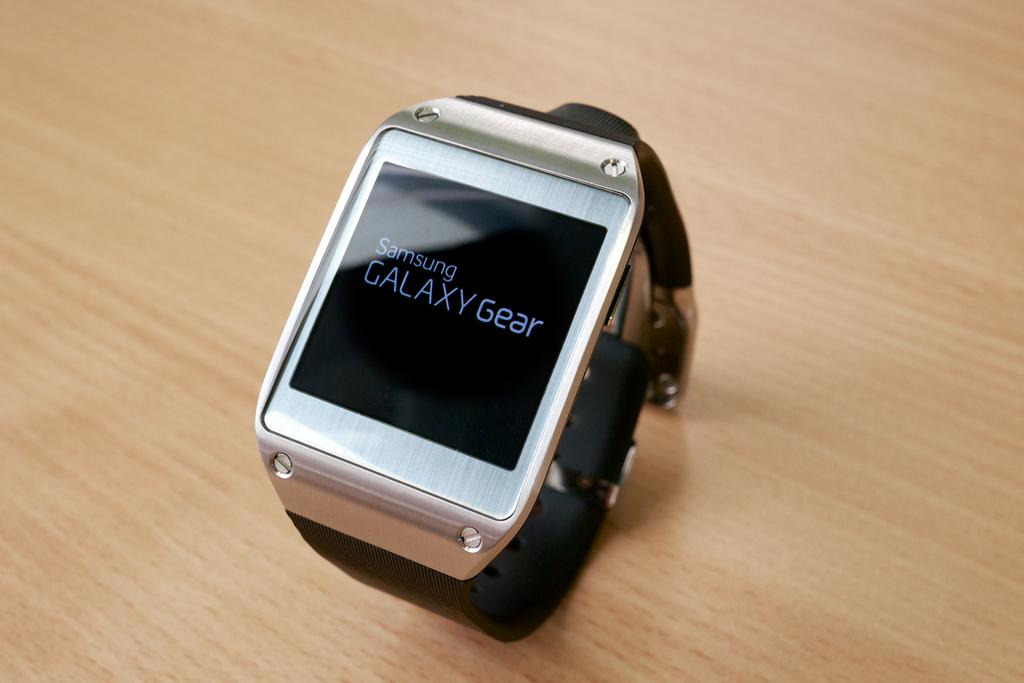<image>
Write a terse but informative summary of the picture. Samsung is one of three words displayed on the face of a watch. 